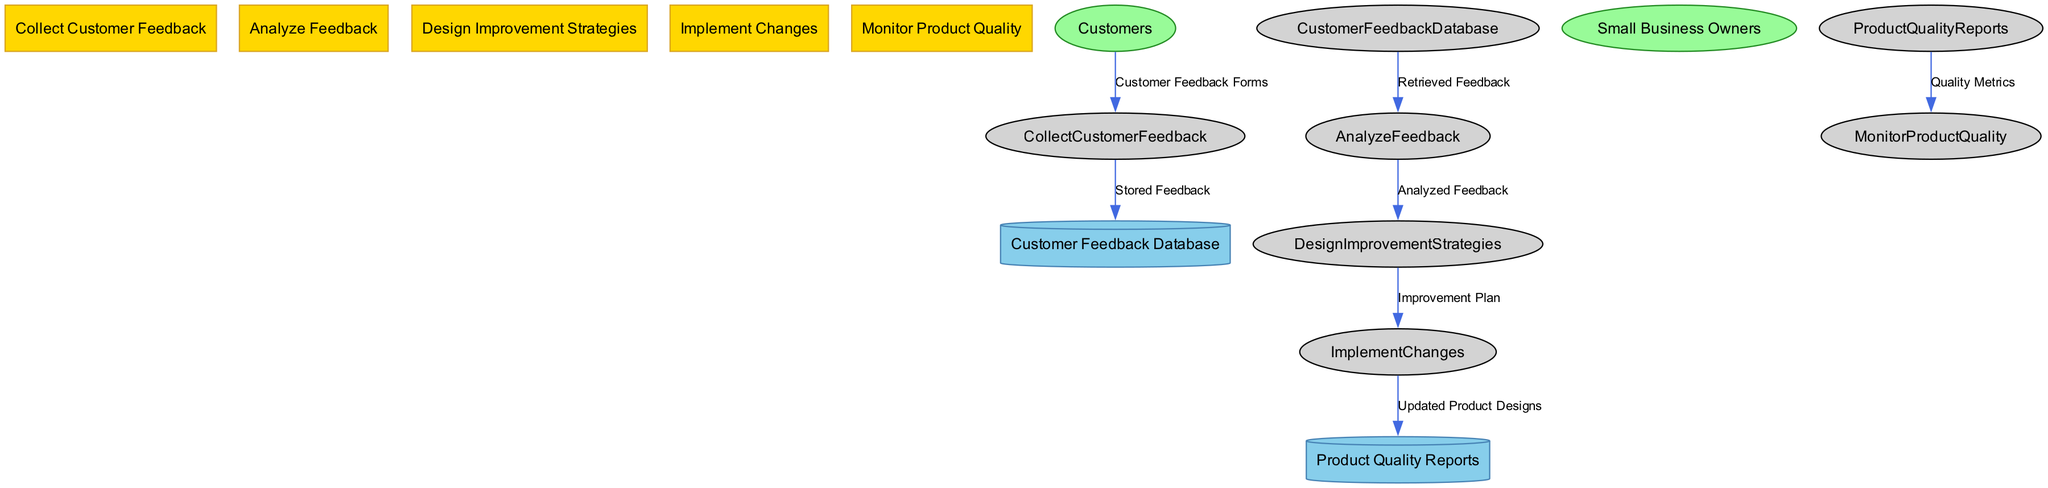What is the first process in the diagram? The first process listed in the diagram is "Collect Customer Feedback." This is directly identified from the section detailing the processes, where it is the first entry under the processes with id "1."
Answer: Collect Customer Feedback How many data flows are represented in the diagram? By reviewing the data flows section, we find there are a total of seven distinct flows moving between various nodes in the diagram, indicating the transfer of data.
Answer: Seven Which external entity provides feedback? The external entity labeled "Customers" refers to individuals who supply feedback on the products, as described in the section detailing external entities with id "1."
Answer: Customers What data is stored in the "Customer Feedback Database"? According to the description of the data stores, the "Customer Feedback Database" specifically contains "Stored Feedback," which is the data that comes from the collection of customer feedback forms.
Answer: Stored Feedback Which process comes after "Analyze Feedback"? The diagram indicates that after the process "Analyze Feedback," the next step is "Design Improvement Strategies," as outlined in the sequence of the processes listed.
Answer: Design Improvement Strategies What type of reports are stored in the "Product Quality Reports"? This data store is described as containing "reports on product quality and performance," indicating the overall quality and assessment of the products post-feedback and improvement processes.
Answer: Reports on product quality and performance What is the last process in the diagram? The last process identified in the sequence is "Monitor Product Quality," which comes after the previous processes have been implemented and assessed.
Answer: Monitor Product Quality What data flows from "Implement Changes" to "Product Quality Reports"? The flow from "Implement Changes" to "Product Quality Reports" is described as "Updated Product Designs," reflecting the outcome of implementing the improvements derived from the feedback analysis.
Answer: Updated Product Designs 